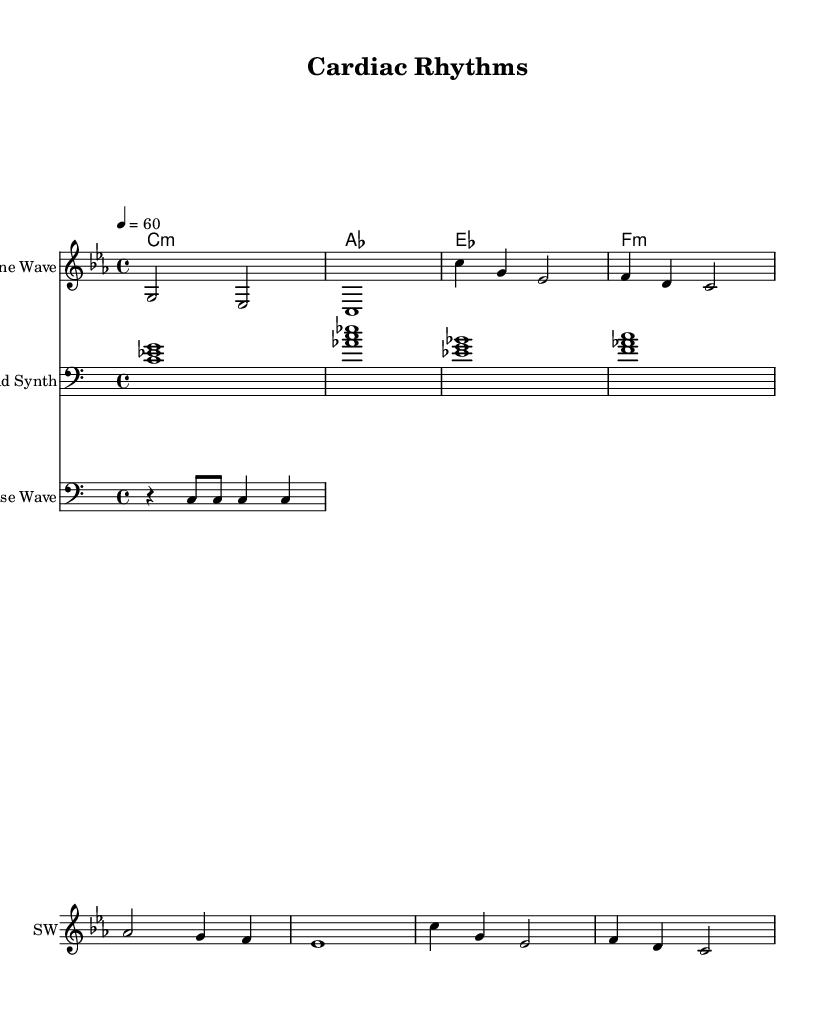What is the key signature of this music? The key signature is C minor, which is indicated at the beginning of the staff with three flats.
Answer: C minor What is the time signature of the piece? The time signature shown is 4/4, which indicates four beats per measure.
Answer: 4/4 What is the tempo marking given in the score? The tempo marking is marked as "4 = 60," indicating that there are 60 beats per minute, with each beat represented by a quarter note.
Answer: 60 How many measures are in the melody section? The melody consists of seven measures based on the notated sections in the score.
Answer: 7 Which instrument is labeled as "Sine Wave"? The instrument labeled as "Sine Wave" refers to the staff where the melody is notated with a treble clef.
Answer: Sine Wave What type of musical structure is used in this piece? The structure chosen consists of an introduction, verse, and bridge sections, typical of ambient electronic music.
Answer: Introduction, verse, bridge Identify the rhythmic element in this score. The rhythmic element is primarily characterized by the rhythm pattern notated in the Pulse Wave staff, comprising rests and eighth notes.
Answer: Rhythm pattern 